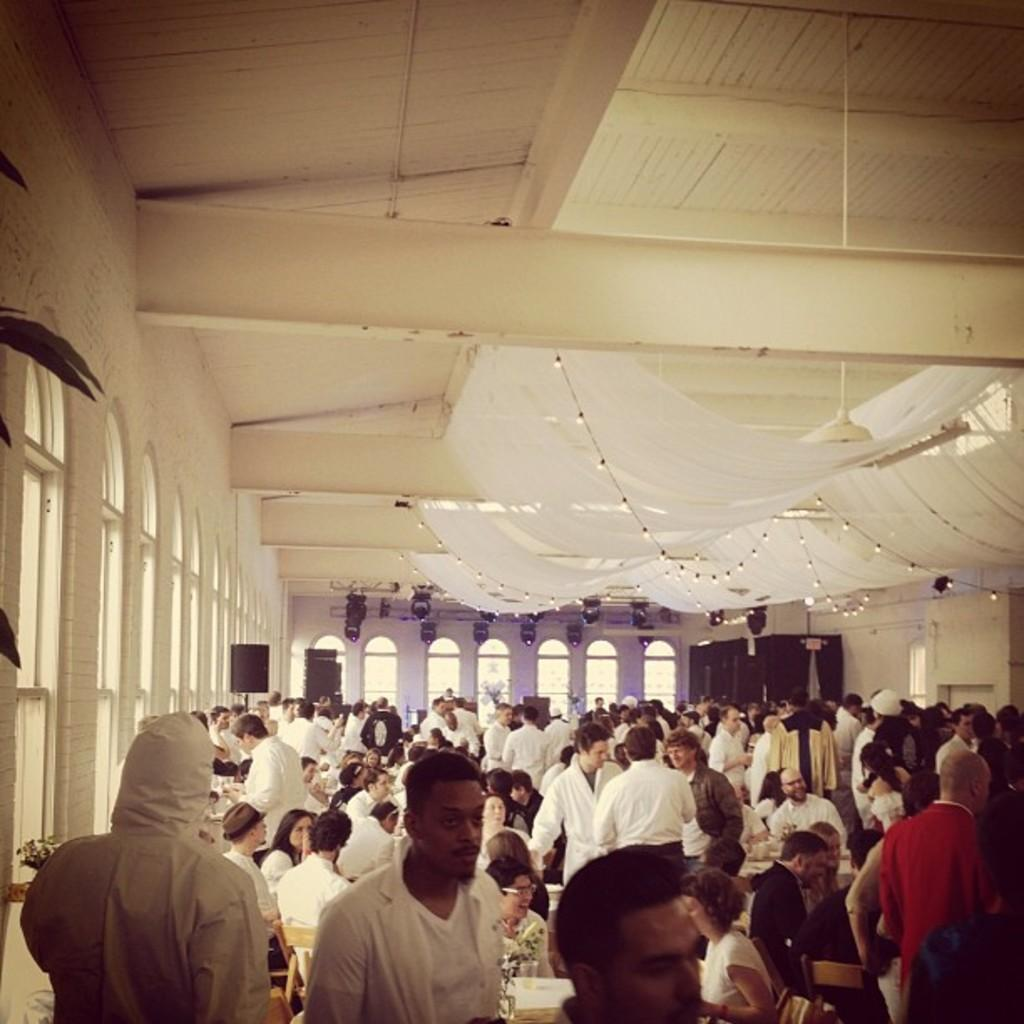What can be seen at the bottom of the picture? There are people, tables, and chairs at the bottom of the picture. What is located on the left side of the picture? There are windows on the left side of the picture. What can be found in the background of the image? In the background, there are lights, speakers, and curtains. Where is the hydrant located in the image? There is no hydrant present in the image. What type of trip can be seen in the image? There is no trip present in the image. 